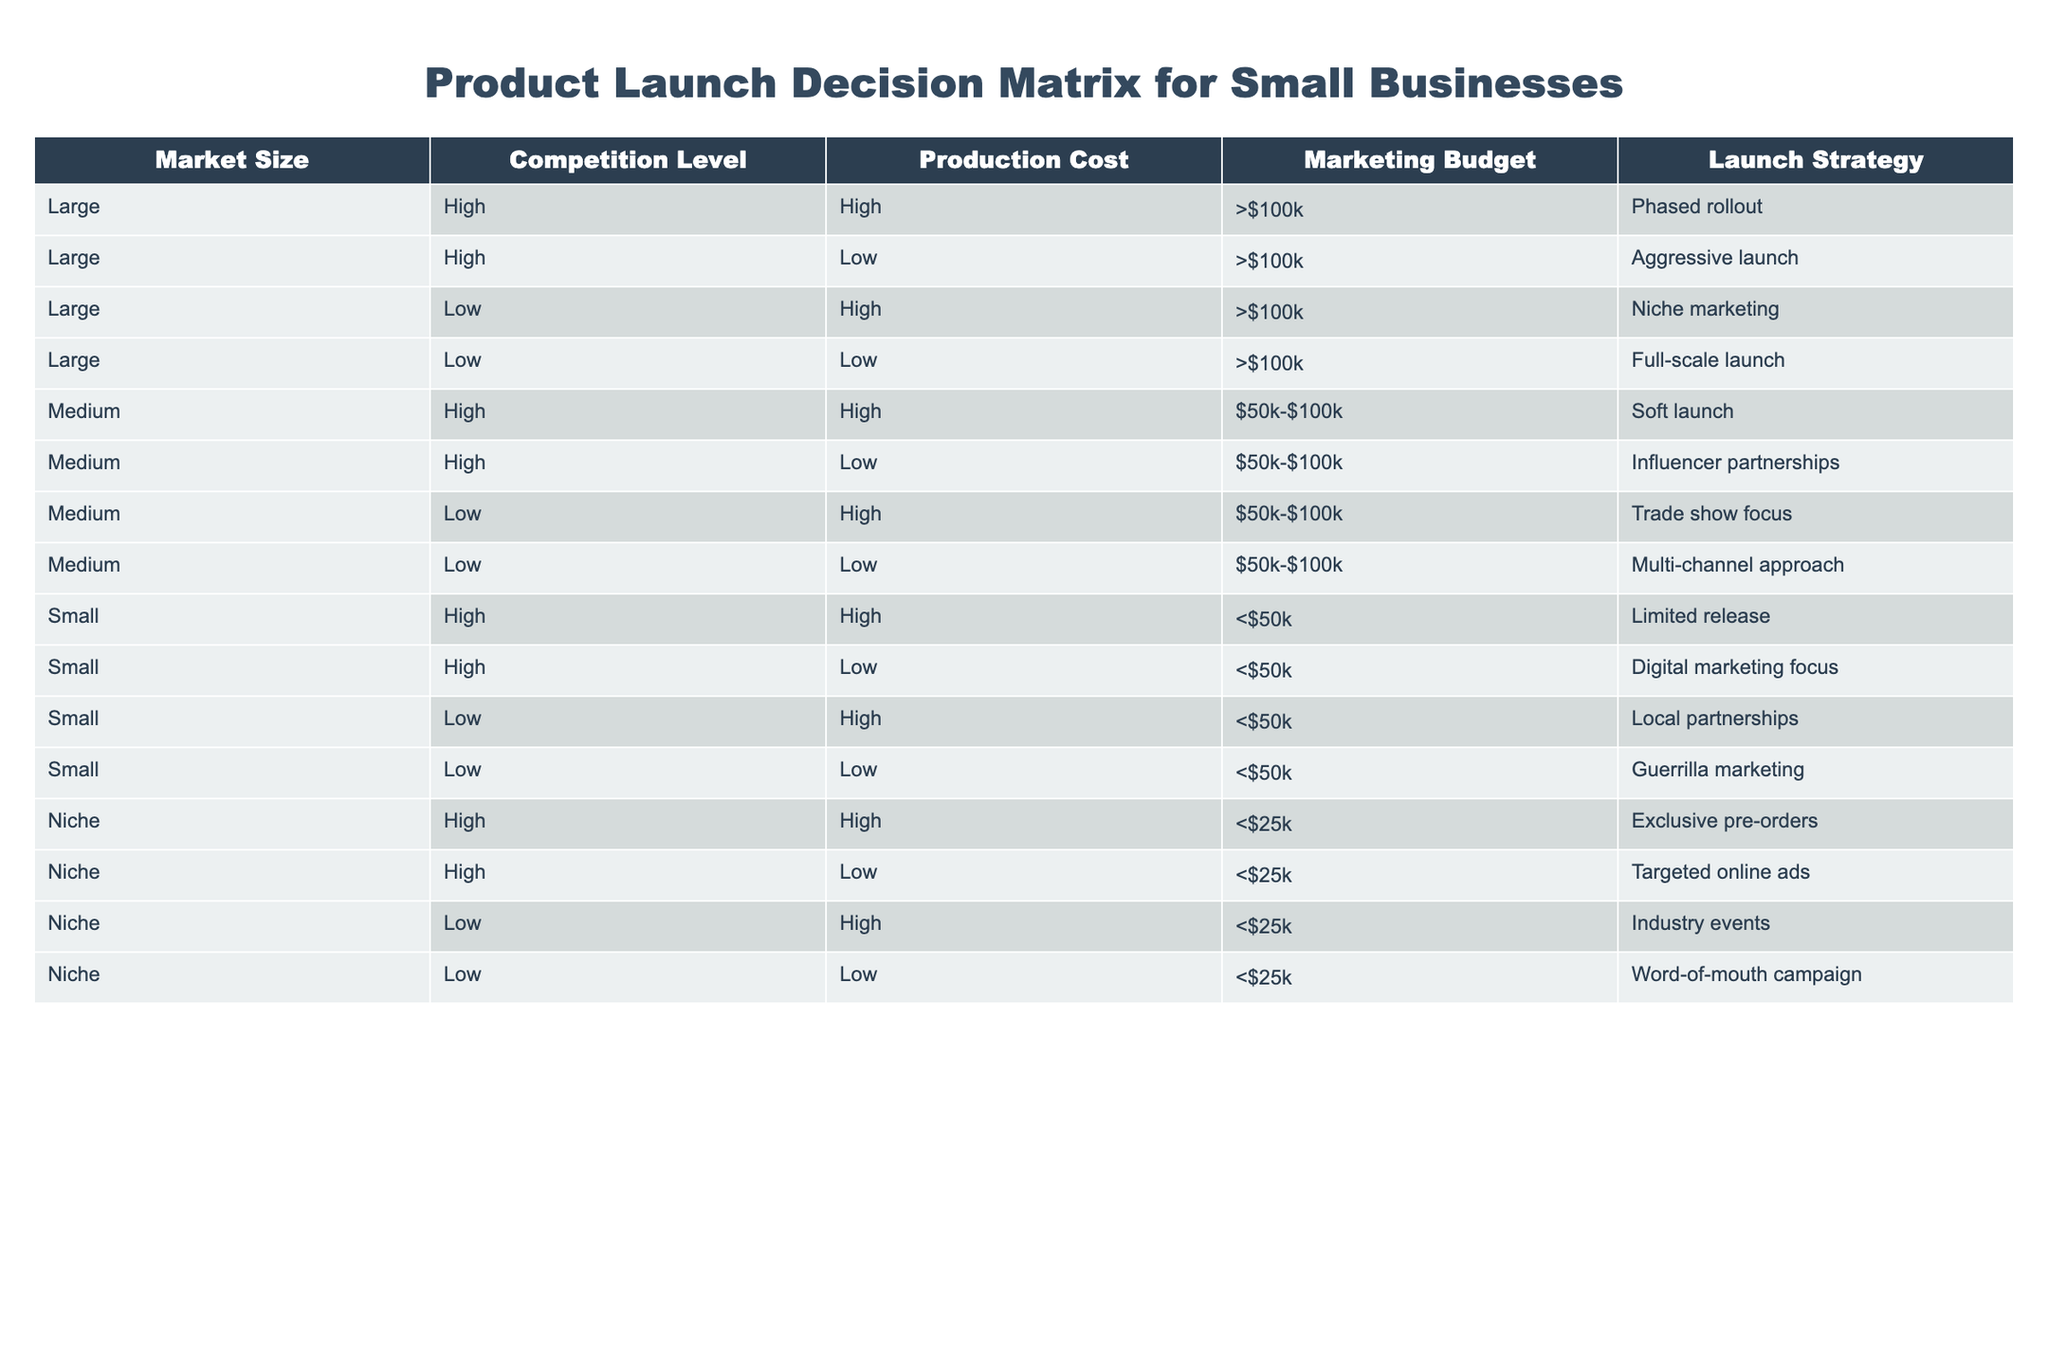What is the production cost for a large market with low competition? In the table, the production costs for a large market with low competition are mentioned in the fourth row, which states that the production cost is low.
Answer: Low What is the launch strategy for a small market with high competition and a low marketing budget? From the table, the relevant row indicates that the launch strategy for a small market that has high competition and low marketing budget is focused on digital marketing.
Answer: Digital marketing focus Is there a launch strategy for a niche market with a low marketing budget? The table shows two entries for a niche market with a low marketing budget, and both entries confirm there are strategies available.
Answer: Yes What is the total number of launch strategies listed for medium market size? There are four entries for medium market size in the table. They represent all the different launch strategies applicable.
Answer: 4 Which market size has the most launch strategies listed? By checking the table, the large market size has four different launch strategies, while medium and small have four and four strategies respectively. Therefore, no specific market size has more strategies than large.
Answer: No What is the average production cost for small market strategies listed in the table? There are four entries for small market which are compared. Three have low production costs, while one has high. The average concludes that a majority favor low production costs across the small market.
Answer: Low Which market size strategy includes industry events? In reviewing the table, the entry that mentions industry events corresponds to the niche market size category and low production cost strategy.
Answer: Niche market size Is aggressive launch an option for a small market with high competition? Evaluating the table shows there is no entry for a small market size that includes an aggressive launch strategy as all mentioned strategies are distinct.
Answer: No What is the only production cost strategy for a niche market with high competition? The table reveals that there is one production cost for a niche market with high competition which is exclusive pre-orders.
Answer: Exclusive pre-orders 